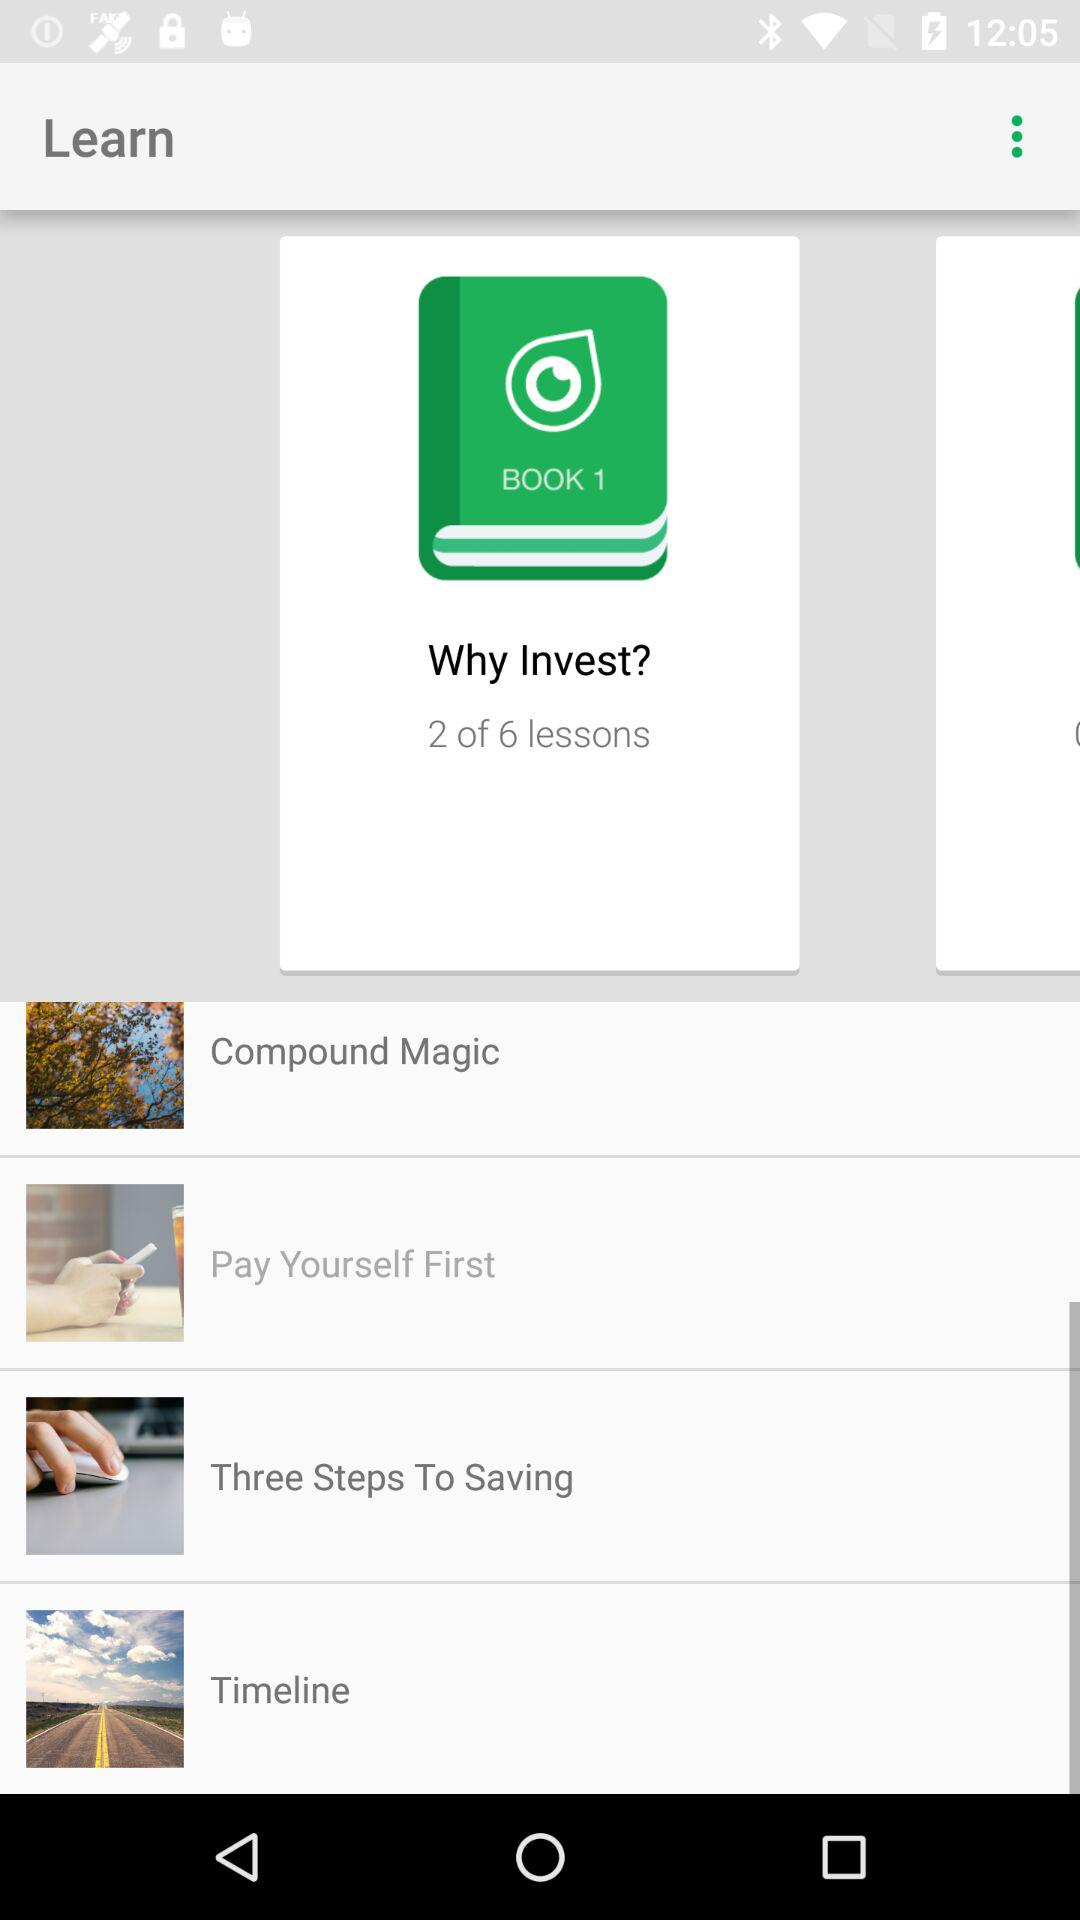How many lessons are there in total?
Answer the question using a single word or phrase. 6 